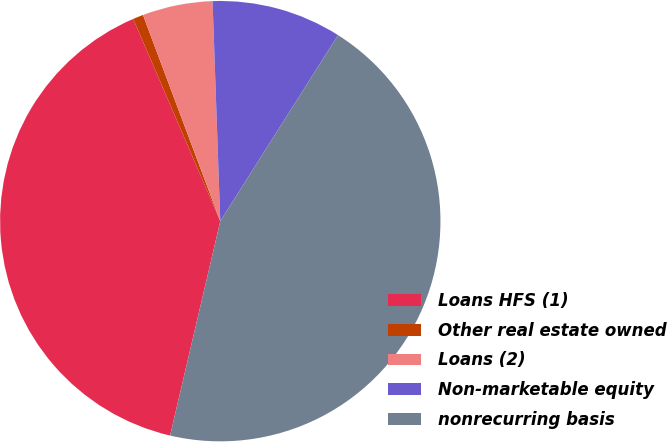Convert chart. <chart><loc_0><loc_0><loc_500><loc_500><pie_chart><fcel>Loans HFS (1)<fcel>Other real estate owned<fcel>Loans (2)<fcel>Non-marketable equity<fcel>nonrecurring basis<nl><fcel>39.87%<fcel>0.76%<fcel>5.15%<fcel>9.54%<fcel>44.68%<nl></chart> 